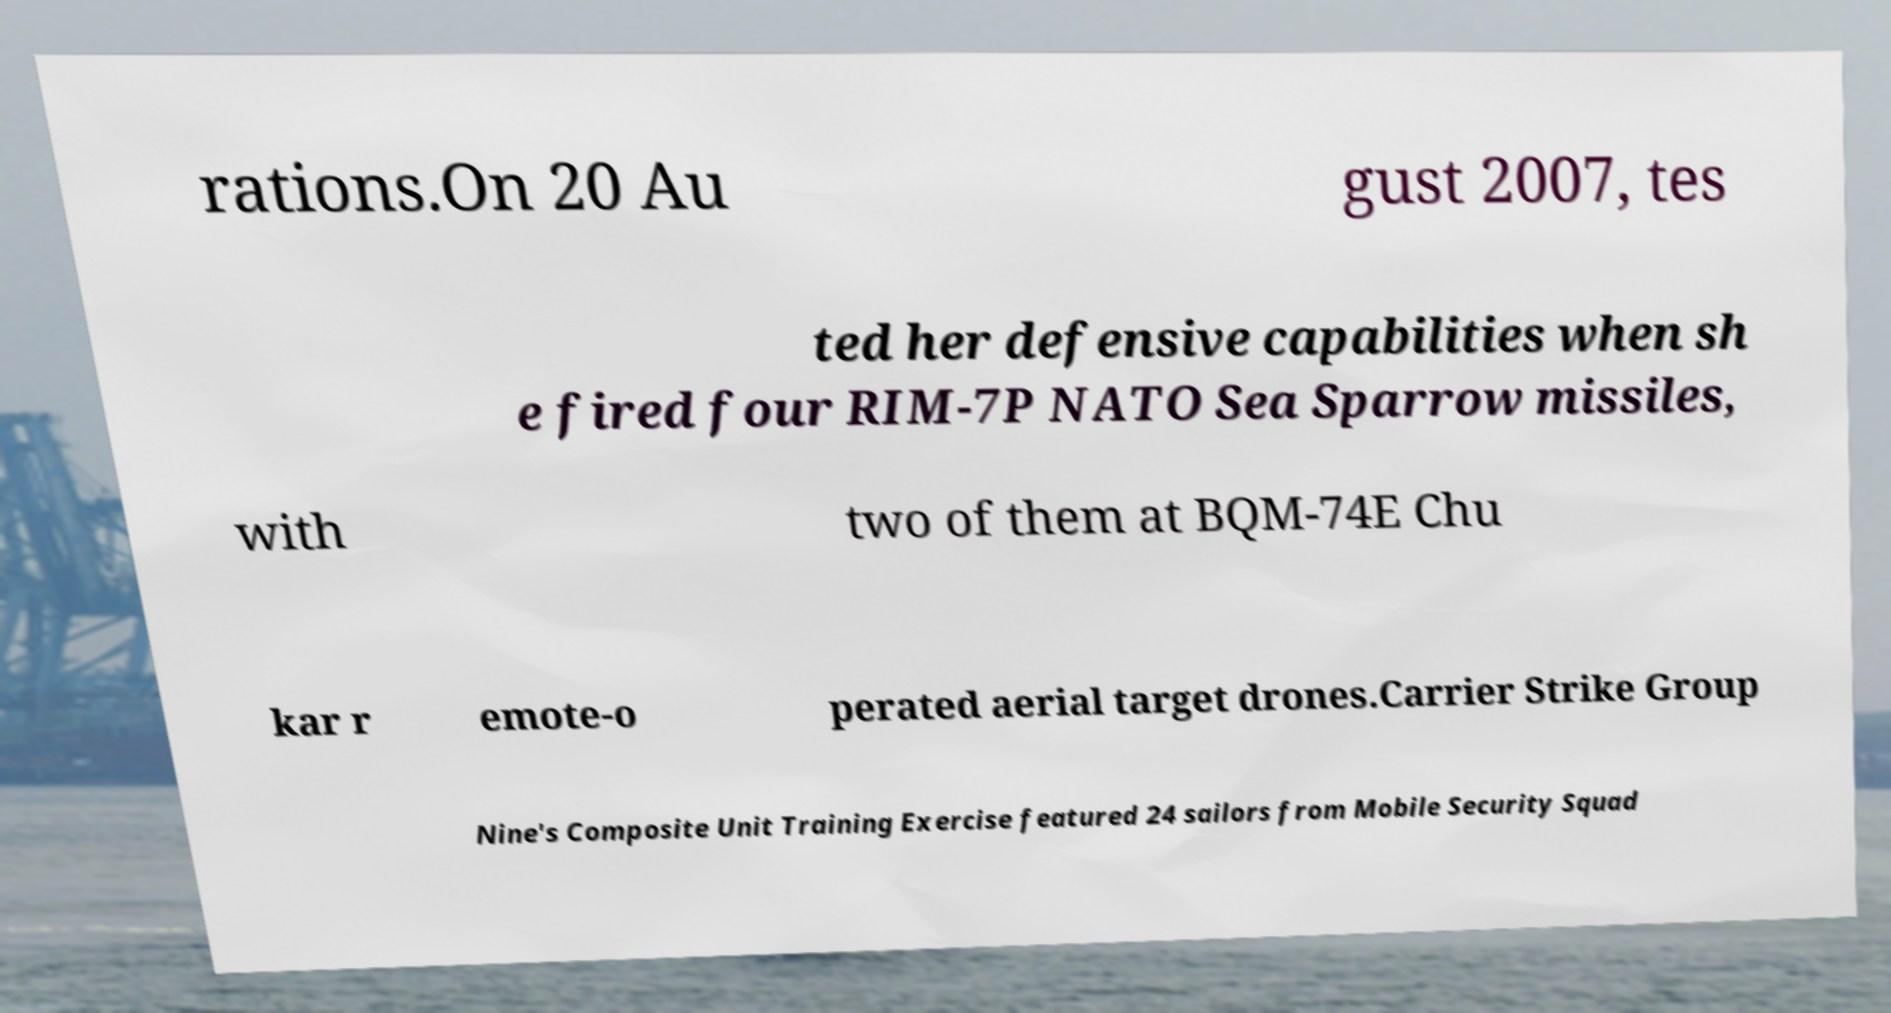Could you assist in decoding the text presented in this image and type it out clearly? rations.On 20 Au gust 2007, tes ted her defensive capabilities when sh e fired four RIM-7P NATO Sea Sparrow missiles, with two of them at BQM-74E Chu kar r emote-o perated aerial target drones.Carrier Strike Group Nine's Composite Unit Training Exercise featured 24 sailors from Mobile Security Squad 